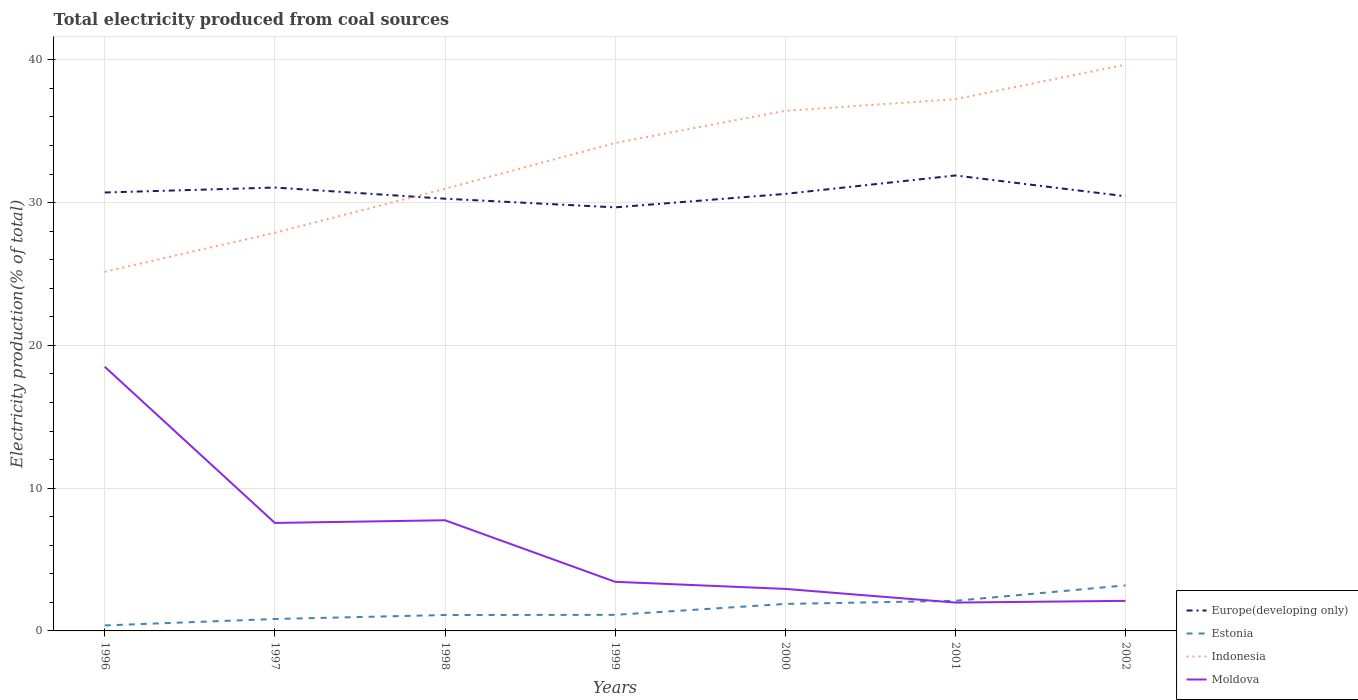How many different coloured lines are there?
Offer a very short reply. 4. Does the line corresponding to Estonia intersect with the line corresponding to Indonesia?
Your answer should be very brief. No. Across all years, what is the maximum total electricity produced in Estonia?
Keep it short and to the point. 0.38. What is the total total electricity produced in Indonesia in the graph?
Your response must be concise. -14.51. What is the difference between the highest and the second highest total electricity produced in Moldova?
Make the answer very short. 16.52. How many years are there in the graph?
Make the answer very short. 7. What is the difference between two consecutive major ticks on the Y-axis?
Provide a short and direct response. 10. Does the graph contain grids?
Offer a terse response. Yes. How are the legend labels stacked?
Provide a succinct answer. Vertical. What is the title of the graph?
Ensure brevity in your answer.  Total electricity produced from coal sources. What is the label or title of the X-axis?
Make the answer very short. Years. What is the Electricity production(% of total) of Europe(developing only) in 1996?
Provide a short and direct response. 30.71. What is the Electricity production(% of total) of Estonia in 1996?
Provide a short and direct response. 0.38. What is the Electricity production(% of total) of Indonesia in 1996?
Ensure brevity in your answer.  25.16. What is the Electricity production(% of total) of Moldova in 1996?
Your answer should be compact. 18.5. What is the Electricity production(% of total) of Europe(developing only) in 1997?
Your answer should be very brief. 31.06. What is the Electricity production(% of total) of Estonia in 1997?
Provide a short and direct response. 0.84. What is the Electricity production(% of total) of Indonesia in 1997?
Make the answer very short. 27.89. What is the Electricity production(% of total) in Moldova in 1997?
Offer a very short reply. 7.56. What is the Electricity production(% of total) of Europe(developing only) in 1998?
Your response must be concise. 30.28. What is the Electricity production(% of total) of Estonia in 1998?
Your answer should be very brief. 1.11. What is the Electricity production(% of total) of Indonesia in 1998?
Your answer should be compact. 30.97. What is the Electricity production(% of total) in Moldova in 1998?
Keep it short and to the point. 7.75. What is the Electricity production(% of total) of Europe(developing only) in 1999?
Give a very brief answer. 29.67. What is the Electricity production(% of total) in Estonia in 1999?
Make the answer very short. 1.12. What is the Electricity production(% of total) in Indonesia in 1999?
Provide a succinct answer. 34.18. What is the Electricity production(% of total) of Moldova in 1999?
Your answer should be very brief. 3.44. What is the Electricity production(% of total) of Europe(developing only) in 2000?
Offer a terse response. 30.61. What is the Electricity production(% of total) in Estonia in 2000?
Provide a short and direct response. 1.89. What is the Electricity production(% of total) of Indonesia in 2000?
Give a very brief answer. 36.43. What is the Electricity production(% of total) of Moldova in 2000?
Offer a terse response. 2.94. What is the Electricity production(% of total) of Europe(developing only) in 2001?
Offer a very short reply. 31.9. What is the Electricity production(% of total) in Estonia in 2001?
Your response must be concise. 2.11. What is the Electricity production(% of total) of Indonesia in 2001?
Give a very brief answer. 37.25. What is the Electricity production(% of total) of Moldova in 2001?
Keep it short and to the point. 1.99. What is the Electricity production(% of total) of Europe(developing only) in 2002?
Your answer should be very brief. 30.45. What is the Electricity production(% of total) of Estonia in 2002?
Your answer should be compact. 3.19. What is the Electricity production(% of total) in Indonesia in 2002?
Offer a very short reply. 39.67. What is the Electricity production(% of total) of Moldova in 2002?
Your answer should be very brief. 2.11. Across all years, what is the maximum Electricity production(% of total) in Europe(developing only)?
Make the answer very short. 31.9. Across all years, what is the maximum Electricity production(% of total) in Estonia?
Your response must be concise. 3.19. Across all years, what is the maximum Electricity production(% of total) in Indonesia?
Provide a short and direct response. 39.67. Across all years, what is the maximum Electricity production(% of total) in Moldova?
Provide a short and direct response. 18.5. Across all years, what is the minimum Electricity production(% of total) of Europe(developing only)?
Your answer should be very brief. 29.67. Across all years, what is the minimum Electricity production(% of total) in Estonia?
Your answer should be compact. 0.38. Across all years, what is the minimum Electricity production(% of total) in Indonesia?
Your answer should be very brief. 25.16. Across all years, what is the minimum Electricity production(% of total) in Moldova?
Provide a succinct answer. 1.99. What is the total Electricity production(% of total) in Europe(developing only) in the graph?
Your response must be concise. 214.68. What is the total Electricity production(% of total) of Estonia in the graph?
Provide a short and direct response. 10.65. What is the total Electricity production(% of total) of Indonesia in the graph?
Your response must be concise. 231.55. What is the total Electricity production(% of total) in Moldova in the graph?
Keep it short and to the point. 44.3. What is the difference between the Electricity production(% of total) of Europe(developing only) in 1996 and that in 1997?
Keep it short and to the point. -0.35. What is the difference between the Electricity production(% of total) of Estonia in 1996 and that in 1997?
Provide a short and direct response. -0.45. What is the difference between the Electricity production(% of total) in Indonesia in 1996 and that in 1997?
Offer a terse response. -2.74. What is the difference between the Electricity production(% of total) of Moldova in 1996 and that in 1997?
Make the answer very short. 10.94. What is the difference between the Electricity production(% of total) in Europe(developing only) in 1996 and that in 1998?
Offer a terse response. 0.44. What is the difference between the Electricity production(% of total) in Estonia in 1996 and that in 1998?
Offer a very short reply. -0.73. What is the difference between the Electricity production(% of total) of Indonesia in 1996 and that in 1998?
Offer a very short reply. -5.81. What is the difference between the Electricity production(% of total) in Moldova in 1996 and that in 1998?
Make the answer very short. 10.75. What is the difference between the Electricity production(% of total) of Europe(developing only) in 1996 and that in 1999?
Provide a short and direct response. 1.04. What is the difference between the Electricity production(% of total) of Estonia in 1996 and that in 1999?
Your answer should be very brief. -0.74. What is the difference between the Electricity production(% of total) in Indonesia in 1996 and that in 1999?
Offer a very short reply. -9.02. What is the difference between the Electricity production(% of total) of Moldova in 1996 and that in 1999?
Provide a succinct answer. 15.06. What is the difference between the Electricity production(% of total) in Europe(developing only) in 1996 and that in 2000?
Offer a terse response. 0.1. What is the difference between the Electricity production(% of total) in Estonia in 1996 and that in 2000?
Give a very brief answer. -1.51. What is the difference between the Electricity production(% of total) of Indonesia in 1996 and that in 2000?
Your answer should be compact. -11.28. What is the difference between the Electricity production(% of total) of Moldova in 1996 and that in 2000?
Offer a terse response. 15.56. What is the difference between the Electricity production(% of total) in Europe(developing only) in 1996 and that in 2001?
Keep it short and to the point. -1.19. What is the difference between the Electricity production(% of total) in Estonia in 1996 and that in 2001?
Your answer should be compact. -1.73. What is the difference between the Electricity production(% of total) of Indonesia in 1996 and that in 2001?
Ensure brevity in your answer.  -12.09. What is the difference between the Electricity production(% of total) of Moldova in 1996 and that in 2001?
Your answer should be very brief. 16.52. What is the difference between the Electricity production(% of total) of Europe(developing only) in 1996 and that in 2002?
Keep it short and to the point. 0.26. What is the difference between the Electricity production(% of total) in Estonia in 1996 and that in 2002?
Offer a terse response. -2.81. What is the difference between the Electricity production(% of total) of Indonesia in 1996 and that in 2002?
Offer a terse response. -14.51. What is the difference between the Electricity production(% of total) in Moldova in 1996 and that in 2002?
Make the answer very short. 16.4. What is the difference between the Electricity production(% of total) of Europe(developing only) in 1997 and that in 1998?
Give a very brief answer. 0.78. What is the difference between the Electricity production(% of total) in Estonia in 1997 and that in 1998?
Your answer should be very brief. -0.28. What is the difference between the Electricity production(% of total) of Indonesia in 1997 and that in 1998?
Your answer should be very brief. -3.08. What is the difference between the Electricity production(% of total) of Moldova in 1997 and that in 1998?
Make the answer very short. -0.19. What is the difference between the Electricity production(% of total) in Europe(developing only) in 1997 and that in 1999?
Provide a succinct answer. 1.39. What is the difference between the Electricity production(% of total) in Estonia in 1997 and that in 1999?
Your answer should be very brief. -0.29. What is the difference between the Electricity production(% of total) of Indonesia in 1997 and that in 1999?
Offer a terse response. -6.29. What is the difference between the Electricity production(% of total) in Moldova in 1997 and that in 1999?
Your response must be concise. 4.12. What is the difference between the Electricity production(% of total) of Europe(developing only) in 1997 and that in 2000?
Ensure brevity in your answer.  0.45. What is the difference between the Electricity production(% of total) of Estonia in 1997 and that in 2000?
Offer a very short reply. -1.06. What is the difference between the Electricity production(% of total) of Indonesia in 1997 and that in 2000?
Offer a terse response. -8.54. What is the difference between the Electricity production(% of total) in Moldova in 1997 and that in 2000?
Provide a short and direct response. 4.62. What is the difference between the Electricity production(% of total) in Europe(developing only) in 1997 and that in 2001?
Your answer should be compact. -0.85. What is the difference between the Electricity production(% of total) of Estonia in 1997 and that in 2001?
Keep it short and to the point. -1.27. What is the difference between the Electricity production(% of total) in Indonesia in 1997 and that in 2001?
Your response must be concise. -9.35. What is the difference between the Electricity production(% of total) of Moldova in 1997 and that in 2001?
Give a very brief answer. 5.58. What is the difference between the Electricity production(% of total) of Europe(developing only) in 1997 and that in 2002?
Your answer should be very brief. 0.61. What is the difference between the Electricity production(% of total) in Estonia in 1997 and that in 2002?
Make the answer very short. -2.35. What is the difference between the Electricity production(% of total) in Indonesia in 1997 and that in 2002?
Give a very brief answer. -11.78. What is the difference between the Electricity production(% of total) of Moldova in 1997 and that in 2002?
Ensure brevity in your answer.  5.46. What is the difference between the Electricity production(% of total) in Europe(developing only) in 1998 and that in 1999?
Provide a short and direct response. 0.61. What is the difference between the Electricity production(% of total) of Estonia in 1998 and that in 1999?
Offer a terse response. -0.01. What is the difference between the Electricity production(% of total) of Indonesia in 1998 and that in 1999?
Your response must be concise. -3.21. What is the difference between the Electricity production(% of total) in Moldova in 1998 and that in 1999?
Ensure brevity in your answer.  4.31. What is the difference between the Electricity production(% of total) in Europe(developing only) in 1998 and that in 2000?
Provide a succinct answer. -0.34. What is the difference between the Electricity production(% of total) of Estonia in 1998 and that in 2000?
Give a very brief answer. -0.78. What is the difference between the Electricity production(% of total) of Indonesia in 1998 and that in 2000?
Your response must be concise. -5.46. What is the difference between the Electricity production(% of total) of Moldova in 1998 and that in 2000?
Your answer should be very brief. 4.81. What is the difference between the Electricity production(% of total) of Europe(developing only) in 1998 and that in 2001?
Provide a short and direct response. -1.63. What is the difference between the Electricity production(% of total) of Estonia in 1998 and that in 2001?
Keep it short and to the point. -1. What is the difference between the Electricity production(% of total) of Indonesia in 1998 and that in 2001?
Offer a terse response. -6.27. What is the difference between the Electricity production(% of total) in Moldova in 1998 and that in 2001?
Provide a short and direct response. 5.77. What is the difference between the Electricity production(% of total) of Europe(developing only) in 1998 and that in 2002?
Your response must be concise. -0.17. What is the difference between the Electricity production(% of total) in Estonia in 1998 and that in 2002?
Offer a very short reply. -2.08. What is the difference between the Electricity production(% of total) of Indonesia in 1998 and that in 2002?
Give a very brief answer. -8.7. What is the difference between the Electricity production(% of total) in Moldova in 1998 and that in 2002?
Provide a short and direct response. 5.65. What is the difference between the Electricity production(% of total) of Europe(developing only) in 1999 and that in 2000?
Keep it short and to the point. -0.94. What is the difference between the Electricity production(% of total) in Estonia in 1999 and that in 2000?
Give a very brief answer. -0.77. What is the difference between the Electricity production(% of total) in Indonesia in 1999 and that in 2000?
Provide a succinct answer. -2.25. What is the difference between the Electricity production(% of total) of Moldova in 1999 and that in 2000?
Ensure brevity in your answer.  0.5. What is the difference between the Electricity production(% of total) in Europe(developing only) in 1999 and that in 2001?
Your answer should be compact. -2.23. What is the difference between the Electricity production(% of total) of Estonia in 1999 and that in 2001?
Keep it short and to the point. -0.99. What is the difference between the Electricity production(% of total) of Indonesia in 1999 and that in 2001?
Make the answer very short. -3.07. What is the difference between the Electricity production(% of total) of Moldova in 1999 and that in 2001?
Your answer should be compact. 1.45. What is the difference between the Electricity production(% of total) of Europe(developing only) in 1999 and that in 2002?
Provide a short and direct response. -0.78. What is the difference between the Electricity production(% of total) in Estonia in 1999 and that in 2002?
Ensure brevity in your answer.  -2.06. What is the difference between the Electricity production(% of total) in Indonesia in 1999 and that in 2002?
Provide a short and direct response. -5.49. What is the difference between the Electricity production(% of total) in Moldova in 1999 and that in 2002?
Your answer should be compact. 1.33. What is the difference between the Electricity production(% of total) in Europe(developing only) in 2000 and that in 2001?
Make the answer very short. -1.29. What is the difference between the Electricity production(% of total) in Estonia in 2000 and that in 2001?
Keep it short and to the point. -0.22. What is the difference between the Electricity production(% of total) in Indonesia in 2000 and that in 2001?
Your response must be concise. -0.81. What is the difference between the Electricity production(% of total) of Moldova in 2000 and that in 2001?
Your response must be concise. 0.96. What is the difference between the Electricity production(% of total) in Europe(developing only) in 2000 and that in 2002?
Your answer should be very brief. 0.16. What is the difference between the Electricity production(% of total) of Estonia in 2000 and that in 2002?
Ensure brevity in your answer.  -1.3. What is the difference between the Electricity production(% of total) in Indonesia in 2000 and that in 2002?
Offer a terse response. -3.24. What is the difference between the Electricity production(% of total) of Moldova in 2000 and that in 2002?
Provide a succinct answer. 0.84. What is the difference between the Electricity production(% of total) of Europe(developing only) in 2001 and that in 2002?
Your answer should be very brief. 1.45. What is the difference between the Electricity production(% of total) in Estonia in 2001 and that in 2002?
Keep it short and to the point. -1.08. What is the difference between the Electricity production(% of total) of Indonesia in 2001 and that in 2002?
Your answer should be very brief. -2.42. What is the difference between the Electricity production(% of total) in Moldova in 2001 and that in 2002?
Your answer should be very brief. -0.12. What is the difference between the Electricity production(% of total) of Europe(developing only) in 1996 and the Electricity production(% of total) of Estonia in 1997?
Give a very brief answer. 29.88. What is the difference between the Electricity production(% of total) of Europe(developing only) in 1996 and the Electricity production(% of total) of Indonesia in 1997?
Make the answer very short. 2.82. What is the difference between the Electricity production(% of total) in Europe(developing only) in 1996 and the Electricity production(% of total) in Moldova in 1997?
Your answer should be very brief. 23.15. What is the difference between the Electricity production(% of total) in Estonia in 1996 and the Electricity production(% of total) in Indonesia in 1997?
Your answer should be very brief. -27.51. What is the difference between the Electricity production(% of total) in Estonia in 1996 and the Electricity production(% of total) in Moldova in 1997?
Ensure brevity in your answer.  -7.18. What is the difference between the Electricity production(% of total) of Indonesia in 1996 and the Electricity production(% of total) of Moldova in 1997?
Ensure brevity in your answer.  17.59. What is the difference between the Electricity production(% of total) of Europe(developing only) in 1996 and the Electricity production(% of total) of Estonia in 1998?
Ensure brevity in your answer.  29.6. What is the difference between the Electricity production(% of total) in Europe(developing only) in 1996 and the Electricity production(% of total) in Indonesia in 1998?
Provide a short and direct response. -0.26. What is the difference between the Electricity production(% of total) of Europe(developing only) in 1996 and the Electricity production(% of total) of Moldova in 1998?
Your answer should be compact. 22.96. What is the difference between the Electricity production(% of total) of Estonia in 1996 and the Electricity production(% of total) of Indonesia in 1998?
Provide a short and direct response. -30.59. What is the difference between the Electricity production(% of total) of Estonia in 1996 and the Electricity production(% of total) of Moldova in 1998?
Ensure brevity in your answer.  -7.37. What is the difference between the Electricity production(% of total) of Indonesia in 1996 and the Electricity production(% of total) of Moldova in 1998?
Your answer should be compact. 17.41. What is the difference between the Electricity production(% of total) of Europe(developing only) in 1996 and the Electricity production(% of total) of Estonia in 1999?
Ensure brevity in your answer.  29.59. What is the difference between the Electricity production(% of total) of Europe(developing only) in 1996 and the Electricity production(% of total) of Indonesia in 1999?
Your answer should be compact. -3.47. What is the difference between the Electricity production(% of total) of Europe(developing only) in 1996 and the Electricity production(% of total) of Moldova in 1999?
Your answer should be compact. 27.27. What is the difference between the Electricity production(% of total) in Estonia in 1996 and the Electricity production(% of total) in Indonesia in 1999?
Make the answer very short. -33.79. What is the difference between the Electricity production(% of total) of Estonia in 1996 and the Electricity production(% of total) of Moldova in 1999?
Offer a very short reply. -3.06. What is the difference between the Electricity production(% of total) in Indonesia in 1996 and the Electricity production(% of total) in Moldova in 1999?
Provide a short and direct response. 21.72. What is the difference between the Electricity production(% of total) in Europe(developing only) in 1996 and the Electricity production(% of total) in Estonia in 2000?
Your answer should be compact. 28.82. What is the difference between the Electricity production(% of total) in Europe(developing only) in 1996 and the Electricity production(% of total) in Indonesia in 2000?
Offer a very short reply. -5.72. What is the difference between the Electricity production(% of total) of Europe(developing only) in 1996 and the Electricity production(% of total) of Moldova in 2000?
Provide a short and direct response. 27.77. What is the difference between the Electricity production(% of total) in Estonia in 1996 and the Electricity production(% of total) in Indonesia in 2000?
Your response must be concise. -36.05. What is the difference between the Electricity production(% of total) in Estonia in 1996 and the Electricity production(% of total) in Moldova in 2000?
Give a very brief answer. -2.56. What is the difference between the Electricity production(% of total) in Indonesia in 1996 and the Electricity production(% of total) in Moldova in 2000?
Provide a short and direct response. 22.21. What is the difference between the Electricity production(% of total) of Europe(developing only) in 1996 and the Electricity production(% of total) of Estonia in 2001?
Your response must be concise. 28.6. What is the difference between the Electricity production(% of total) of Europe(developing only) in 1996 and the Electricity production(% of total) of Indonesia in 2001?
Give a very brief answer. -6.53. What is the difference between the Electricity production(% of total) of Europe(developing only) in 1996 and the Electricity production(% of total) of Moldova in 2001?
Provide a short and direct response. 28.73. What is the difference between the Electricity production(% of total) in Estonia in 1996 and the Electricity production(% of total) in Indonesia in 2001?
Offer a terse response. -36.86. What is the difference between the Electricity production(% of total) of Estonia in 1996 and the Electricity production(% of total) of Moldova in 2001?
Your answer should be compact. -1.6. What is the difference between the Electricity production(% of total) of Indonesia in 1996 and the Electricity production(% of total) of Moldova in 2001?
Your answer should be compact. 23.17. What is the difference between the Electricity production(% of total) of Europe(developing only) in 1996 and the Electricity production(% of total) of Estonia in 2002?
Offer a terse response. 27.52. What is the difference between the Electricity production(% of total) in Europe(developing only) in 1996 and the Electricity production(% of total) in Indonesia in 2002?
Keep it short and to the point. -8.96. What is the difference between the Electricity production(% of total) in Europe(developing only) in 1996 and the Electricity production(% of total) in Moldova in 2002?
Your answer should be compact. 28.61. What is the difference between the Electricity production(% of total) of Estonia in 1996 and the Electricity production(% of total) of Indonesia in 2002?
Provide a succinct answer. -39.28. What is the difference between the Electricity production(% of total) in Estonia in 1996 and the Electricity production(% of total) in Moldova in 2002?
Your answer should be very brief. -1.72. What is the difference between the Electricity production(% of total) of Indonesia in 1996 and the Electricity production(% of total) of Moldova in 2002?
Your response must be concise. 23.05. What is the difference between the Electricity production(% of total) in Europe(developing only) in 1997 and the Electricity production(% of total) in Estonia in 1998?
Provide a succinct answer. 29.94. What is the difference between the Electricity production(% of total) in Europe(developing only) in 1997 and the Electricity production(% of total) in Indonesia in 1998?
Offer a terse response. 0.09. What is the difference between the Electricity production(% of total) in Europe(developing only) in 1997 and the Electricity production(% of total) in Moldova in 1998?
Your answer should be very brief. 23.31. What is the difference between the Electricity production(% of total) in Estonia in 1997 and the Electricity production(% of total) in Indonesia in 1998?
Ensure brevity in your answer.  -30.14. What is the difference between the Electricity production(% of total) of Estonia in 1997 and the Electricity production(% of total) of Moldova in 1998?
Ensure brevity in your answer.  -6.92. What is the difference between the Electricity production(% of total) of Indonesia in 1997 and the Electricity production(% of total) of Moldova in 1998?
Ensure brevity in your answer.  20.14. What is the difference between the Electricity production(% of total) of Europe(developing only) in 1997 and the Electricity production(% of total) of Estonia in 1999?
Keep it short and to the point. 29.93. What is the difference between the Electricity production(% of total) of Europe(developing only) in 1997 and the Electricity production(% of total) of Indonesia in 1999?
Offer a very short reply. -3.12. What is the difference between the Electricity production(% of total) of Europe(developing only) in 1997 and the Electricity production(% of total) of Moldova in 1999?
Provide a succinct answer. 27.62. What is the difference between the Electricity production(% of total) of Estonia in 1997 and the Electricity production(% of total) of Indonesia in 1999?
Make the answer very short. -33.34. What is the difference between the Electricity production(% of total) in Estonia in 1997 and the Electricity production(% of total) in Moldova in 1999?
Your answer should be compact. -2.61. What is the difference between the Electricity production(% of total) in Indonesia in 1997 and the Electricity production(% of total) in Moldova in 1999?
Keep it short and to the point. 24.45. What is the difference between the Electricity production(% of total) in Europe(developing only) in 1997 and the Electricity production(% of total) in Estonia in 2000?
Provide a succinct answer. 29.17. What is the difference between the Electricity production(% of total) in Europe(developing only) in 1997 and the Electricity production(% of total) in Indonesia in 2000?
Offer a very short reply. -5.38. What is the difference between the Electricity production(% of total) of Europe(developing only) in 1997 and the Electricity production(% of total) of Moldova in 2000?
Make the answer very short. 28.12. What is the difference between the Electricity production(% of total) in Estonia in 1997 and the Electricity production(% of total) in Indonesia in 2000?
Your answer should be compact. -35.6. What is the difference between the Electricity production(% of total) in Estonia in 1997 and the Electricity production(% of total) in Moldova in 2000?
Your answer should be very brief. -2.11. What is the difference between the Electricity production(% of total) in Indonesia in 1997 and the Electricity production(% of total) in Moldova in 2000?
Offer a terse response. 24.95. What is the difference between the Electricity production(% of total) of Europe(developing only) in 1997 and the Electricity production(% of total) of Estonia in 2001?
Ensure brevity in your answer.  28.95. What is the difference between the Electricity production(% of total) in Europe(developing only) in 1997 and the Electricity production(% of total) in Indonesia in 2001?
Make the answer very short. -6.19. What is the difference between the Electricity production(% of total) of Europe(developing only) in 1997 and the Electricity production(% of total) of Moldova in 2001?
Provide a short and direct response. 29.07. What is the difference between the Electricity production(% of total) in Estonia in 1997 and the Electricity production(% of total) in Indonesia in 2001?
Your answer should be compact. -36.41. What is the difference between the Electricity production(% of total) of Estonia in 1997 and the Electricity production(% of total) of Moldova in 2001?
Offer a terse response. -1.15. What is the difference between the Electricity production(% of total) in Indonesia in 1997 and the Electricity production(% of total) in Moldova in 2001?
Ensure brevity in your answer.  25.91. What is the difference between the Electricity production(% of total) of Europe(developing only) in 1997 and the Electricity production(% of total) of Estonia in 2002?
Ensure brevity in your answer.  27.87. What is the difference between the Electricity production(% of total) in Europe(developing only) in 1997 and the Electricity production(% of total) in Indonesia in 2002?
Your answer should be very brief. -8.61. What is the difference between the Electricity production(% of total) in Europe(developing only) in 1997 and the Electricity production(% of total) in Moldova in 2002?
Ensure brevity in your answer.  28.95. What is the difference between the Electricity production(% of total) in Estonia in 1997 and the Electricity production(% of total) in Indonesia in 2002?
Provide a short and direct response. -38.83. What is the difference between the Electricity production(% of total) in Estonia in 1997 and the Electricity production(% of total) in Moldova in 2002?
Offer a terse response. -1.27. What is the difference between the Electricity production(% of total) in Indonesia in 1997 and the Electricity production(% of total) in Moldova in 2002?
Your answer should be very brief. 25.79. What is the difference between the Electricity production(% of total) of Europe(developing only) in 1998 and the Electricity production(% of total) of Estonia in 1999?
Offer a terse response. 29.15. What is the difference between the Electricity production(% of total) in Europe(developing only) in 1998 and the Electricity production(% of total) in Indonesia in 1999?
Offer a terse response. -3.9. What is the difference between the Electricity production(% of total) of Europe(developing only) in 1998 and the Electricity production(% of total) of Moldova in 1999?
Offer a terse response. 26.84. What is the difference between the Electricity production(% of total) in Estonia in 1998 and the Electricity production(% of total) in Indonesia in 1999?
Make the answer very short. -33.06. What is the difference between the Electricity production(% of total) of Estonia in 1998 and the Electricity production(% of total) of Moldova in 1999?
Your response must be concise. -2.33. What is the difference between the Electricity production(% of total) of Indonesia in 1998 and the Electricity production(% of total) of Moldova in 1999?
Ensure brevity in your answer.  27.53. What is the difference between the Electricity production(% of total) in Europe(developing only) in 1998 and the Electricity production(% of total) in Estonia in 2000?
Offer a very short reply. 28.38. What is the difference between the Electricity production(% of total) in Europe(developing only) in 1998 and the Electricity production(% of total) in Indonesia in 2000?
Your response must be concise. -6.16. What is the difference between the Electricity production(% of total) in Europe(developing only) in 1998 and the Electricity production(% of total) in Moldova in 2000?
Make the answer very short. 27.33. What is the difference between the Electricity production(% of total) of Estonia in 1998 and the Electricity production(% of total) of Indonesia in 2000?
Your answer should be very brief. -35.32. What is the difference between the Electricity production(% of total) in Estonia in 1998 and the Electricity production(% of total) in Moldova in 2000?
Ensure brevity in your answer.  -1.83. What is the difference between the Electricity production(% of total) of Indonesia in 1998 and the Electricity production(% of total) of Moldova in 2000?
Make the answer very short. 28.03. What is the difference between the Electricity production(% of total) of Europe(developing only) in 1998 and the Electricity production(% of total) of Estonia in 2001?
Your answer should be compact. 28.17. What is the difference between the Electricity production(% of total) of Europe(developing only) in 1998 and the Electricity production(% of total) of Indonesia in 2001?
Provide a succinct answer. -6.97. What is the difference between the Electricity production(% of total) of Europe(developing only) in 1998 and the Electricity production(% of total) of Moldova in 2001?
Offer a terse response. 28.29. What is the difference between the Electricity production(% of total) of Estonia in 1998 and the Electricity production(% of total) of Indonesia in 2001?
Provide a short and direct response. -36.13. What is the difference between the Electricity production(% of total) in Estonia in 1998 and the Electricity production(% of total) in Moldova in 2001?
Your answer should be very brief. -0.87. What is the difference between the Electricity production(% of total) of Indonesia in 1998 and the Electricity production(% of total) of Moldova in 2001?
Ensure brevity in your answer.  28.99. What is the difference between the Electricity production(% of total) of Europe(developing only) in 1998 and the Electricity production(% of total) of Estonia in 2002?
Offer a terse response. 27.09. What is the difference between the Electricity production(% of total) of Europe(developing only) in 1998 and the Electricity production(% of total) of Indonesia in 2002?
Provide a short and direct response. -9.39. What is the difference between the Electricity production(% of total) of Europe(developing only) in 1998 and the Electricity production(% of total) of Moldova in 2002?
Provide a succinct answer. 28.17. What is the difference between the Electricity production(% of total) of Estonia in 1998 and the Electricity production(% of total) of Indonesia in 2002?
Offer a very short reply. -38.55. What is the difference between the Electricity production(% of total) of Estonia in 1998 and the Electricity production(% of total) of Moldova in 2002?
Keep it short and to the point. -0.99. What is the difference between the Electricity production(% of total) in Indonesia in 1998 and the Electricity production(% of total) in Moldova in 2002?
Offer a terse response. 28.87. What is the difference between the Electricity production(% of total) of Europe(developing only) in 1999 and the Electricity production(% of total) of Estonia in 2000?
Your response must be concise. 27.78. What is the difference between the Electricity production(% of total) of Europe(developing only) in 1999 and the Electricity production(% of total) of Indonesia in 2000?
Make the answer very short. -6.76. What is the difference between the Electricity production(% of total) of Europe(developing only) in 1999 and the Electricity production(% of total) of Moldova in 2000?
Make the answer very short. 26.73. What is the difference between the Electricity production(% of total) in Estonia in 1999 and the Electricity production(% of total) in Indonesia in 2000?
Your answer should be very brief. -35.31. What is the difference between the Electricity production(% of total) in Estonia in 1999 and the Electricity production(% of total) in Moldova in 2000?
Offer a very short reply. -1.82. What is the difference between the Electricity production(% of total) in Indonesia in 1999 and the Electricity production(% of total) in Moldova in 2000?
Offer a terse response. 31.24. What is the difference between the Electricity production(% of total) in Europe(developing only) in 1999 and the Electricity production(% of total) in Estonia in 2001?
Provide a succinct answer. 27.56. What is the difference between the Electricity production(% of total) of Europe(developing only) in 1999 and the Electricity production(% of total) of Indonesia in 2001?
Make the answer very short. -7.58. What is the difference between the Electricity production(% of total) in Europe(developing only) in 1999 and the Electricity production(% of total) in Moldova in 2001?
Ensure brevity in your answer.  27.68. What is the difference between the Electricity production(% of total) of Estonia in 1999 and the Electricity production(% of total) of Indonesia in 2001?
Provide a short and direct response. -36.12. What is the difference between the Electricity production(% of total) in Estonia in 1999 and the Electricity production(% of total) in Moldova in 2001?
Your answer should be very brief. -0.86. What is the difference between the Electricity production(% of total) in Indonesia in 1999 and the Electricity production(% of total) in Moldova in 2001?
Ensure brevity in your answer.  32.19. What is the difference between the Electricity production(% of total) in Europe(developing only) in 1999 and the Electricity production(% of total) in Estonia in 2002?
Give a very brief answer. 26.48. What is the difference between the Electricity production(% of total) of Europe(developing only) in 1999 and the Electricity production(% of total) of Indonesia in 2002?
Keep it short and to the point. -10. What is the difference between the Electricity production(% of total) in Europe(developing only) in 1999 and the Electricity production(% of total) in Moldova in 2002?
Offer a terse response. 27.56. What is the difference between the Electricity production(% of total) of Estonia in 1999 and the Electricity production(% of total) of Indonesia in 2002?
Provide a succinct answer. -38.54. What is the difference between the Electricity production(% of total) of Estonia in 1999 and the Electricity production(% of total) of Moldova in 2002?
Your answer should be very brief. -0.98. What is the difference between the Electricity production(% of total) of Indonesia in 1999 and the Electricity production(% of total) of Moldova in 2002?
Offer a terse response. 32.07. What is the difference between the Electricity production(% of total) of Europe(developing only) in 2000 and the Electricity production(% of total) of Estonia in 2001?
Your response must be concise. 28.5. What is the difference between the Electricity production(% of total) of Europe(developing only) in 2000 and the Electricity production(% of total) of Indonesia in 2001?
Keep it short and to the point. -6.63. What is the difference between the Electricity production(% of total) of Europe(developing only) in 2000 and the Electricity production(% of total) of Moldova in 2001?
Offer a terse response. 28.63. What is the difference between the Electricity production(% of total) of Estonia in 2000 and the Electricity production(% of total) of Indonesia in 2001?
Ensure brevity in your answer.  -35.35. What is the difference between the Electricity production(% of total) in Estonia in 2000 and the Electricity production(% of total) in Moldova in 2001?
Provide a succinct answer. -0.1. What is the difference between the Electricity production(% of total) in Indonesia in 2000 and the Electricity production(% of total) in Moldova in 2001?
Your response must be concise. 34.45. What is the difference between the Electricity production(% of total) in Europe(developing only) in 2000 and the Electricity production(% of total) in Estonia in 2002?
Keep it short and to the point. 27.42. What is the difference between the Electricity production(% of total) in Europe(developing only) in 2000 and the Electricity production(% of total) in Indonesia in 2002?
Your answer should be very brief. -9.06. What is the difference between the Electricity production(% of total) of Europe(developing only) in 2000 and the Electricity production(% of total) of Moldova in 2002?
Provide a short and direct response. 28.51. What is the difference between the Electricity production(% of total) of Estonia in 2000 and the Electricity production(% of total) of Indonesia in 2002?
Your response must be concise. -37.78. What is the difference between the Electricity production(% of total) in Estonia in 2000 and the Electricity production(% of total) in Moldova in 2002?
Keep it short and to the point. -0.21. What is the difference between the Electricity production(% of total) in Indonesia in 2000 and the Electricity production(% of total) in Moldova in 2002?
Keep it short and to the point. 34.33. What is the difference between the Electricity production(% of total) in Europe(developing only) in 2001 and the Electricity production(% of total) in Estonia in 2002?
Your answer should be very brief. 28.71. What is the difference between the Electricity production(% of total) of Europe(developing only) in 2001 and the Electricity production(% of total) of Indonesia in 2002?
Make the answer very short. -7.77. What is the difference between the Electricity production(% of total) in Europe(developing only) in 2001 and the Electricity production(% of total) in Moldova in 2002?
Offer a terse response. 29.8. What is the difference between the Electricity production(% of total) in Estonia in 2001 and the Electricity production(% of total) in Indonesia in 2002?
Give a very brief answer. -37.56. What is the difference between the Electricity production(% of total) in Estonia in 2001 and the Electricity production(% of total) in Moldova in 2002?
Provide a succinct answer. 0. What is the difference between the Electricity production(% of total) in Indonesia in 2001 and the Electricity production(% of total) in Moldova in 2002?
Keep it short and to the point. 35.14. What is the average Electricity production(% of total) in Europe(developing only) per year?
Ensure brevity in your answer.  30.67. What is the average Electricity production(% of total) in Estonia per year?
Make the answer very short. 1.52. What is the average Electricity production(% of total) of Indonesia per year?
Offer a terse response. 33.08. What is the average Electricity production(% of total) in Moldova per year?
Your response must be concise. 6.33. In the year 1996, what is the difference between the Electricity production(% of total) of Europe(developing only) and Electricity production(% of total) of Estonia?
Ensure brevity in your answer.  30.33. In the year 1996, what is the difference between the Electricity production(% of total) in Europe(developing only) and Electricity production(% of total) in Indonesia?
Your answer should be compact. 5.55. In the year 1996, what is the difference between the Electricity production(% of total) of Europe(developing only) and Electricity production(% of total) of Moldova?
Keep it short and to the point. 12.21. In the year 1996, what is the difference between the Electricity production(% of total) of Estonia and Electricity production(% of total) of Indonesia?
Offer a very short reply. -24.77. In the year 1996, what is the difference between the Electricity production(% of total) in Estonia and Electricity production(% of total) in Moldova?
Your answer should be compact. -18.12. In the year 1996, what is the difference between the Electricity production(% of total) of Indonesia and Electricity production(% of total) of Moldova?
Make the answer very short. 6.65. In the year 1997, what is the difference between the Electricity production(% of total) in Europe(developing only) and Electricity production(% of total) in Estonia?
Ensure brevity in your answer.  30.22. In the year 1997, what is the difference between the Electricity production(% of total) in Europe(developing only) and Electricity production(% of total) in Indonesia?
Your answer should be very brief. 3.17. In the year 1997, what is the difference between the Electricity production(% of total) in Europe(developing only) and Electricity production(% of total) in Moldova?
Your answer should be very brief. 23.49. In the year 1997, what is the difference between the Electricity production(% of total) in Estonia and Electricity production(% of total) in Indonesia?
Provide a succinct answer. -27.06. In the year 1997, what is the difference between the Electricity production(% of total) in Estonia and Electricity production(% of total) in Moldova?
Make the answer very short. -6.73. In the year 1997, what is the difference between the Electricity production(% of total) of Indonesia and Electricity production(% of total) of Moldova?
Offer a very short reply. 20.33. In the year 1998, what is the difference between the Electricity production(% of total) in Europe(developing only) and Electricity production(% of total) in Estonia?
Provide a short and direct response. 29.16. In the year 1998, what is the difference between the Electricity production(% of total) in Europe(developing only) and Electricity production(% of total) in Indonesia?
Your response must be concise. -0.7. In the year 1998, what is the difference between the Electricity production(% of total) in Europe(developing only) and Electricity production(% of total) in Moldova?
Your response must be concise. 22.52. In the year 1998, what is the difference between the Electricity production(% of total) of Estonia and Electricity production(% of total) of Indonesia?
Provide a succinct answer. -29.86. In the year 1998, what is the difference between the Electricity production(% of total) in Estonia and Electricity production(% of total) in Moldova?
Your answer should be very brief. -6.64. In the year 1998, what is the difference between the Electricity production(% of total) of Indonesia and Electricity production(% of total) of Moldova?
Your answer should be very brief. 23.22. In the year 1999, what is the difference between the Electricity production(% of total) in Europe(developing only) and Electricity production(% of total) in Estonia?
Provide a short and direct response. 28.55. In the year 1999, what is the difference between the Electricity production(% of total) of Europe(developing only) and Electricity production(% of total) of Indonesia?
Provide a succinct answer. -4.51. In the year 1999, what is the difference between the Electricity production(% of total) in Europe(developing only) and Electricity production(% of total) in Moldova?
Offer a terse response. 26.23. In the year 1999, what is the difference between the Electricity production(% of total) of Estonia and Electricity production(% of total) of Indonesia?
Provide a succinct answer. -33.05. In the year 1999, what is the difference between the Electricity production(% of total) of Estonia and Electricity production(% of total) of Moldova?
Offer a very short reply. -2.32. In the year 1999, what is the difference between the Electricity production(% of total) in Indonesia and Electricity production(% of total) in Moldova?
Offer a very short reply. 30.74. In the year 2000, what is the difference between the Electricity production(% of total) of Europe(developing only) and Electricity production(% of total) of Estonia?
Give a very brief answer. 28.72. In the year 2000, what is the difference between the Electricity production(% of total) in Europe(developing only) and Electricity production(% of total) in Indonesia?
Offer a very short reply. -5.82. In the year 2000, what is the difference between the Electricity production(% of total) in Europe(developing only) and Electricity production(% of total) in Moldova?
Your answer should be compact. 27.67. In the year 2000, what is the difference between the Electricity production(% of total) in Estonia and Electricity production(% of total) in Indonesia?
Your answer should be compact. -34.54. In the year 2000, what is the difference between the Electricity production(% of total) of Estonia and Electricity production(% of total) of Moldova?
Offer a terse response. -1.05. In the year 2000, what is the difference between the Electricity production(% of total) of Indonesia and Electricity production(% of total) of Moldova?
Provide a short and direct response. 33.49. In the year 2001, what is the difference between the Electricity production(% of total) in Europe(developing only) and Electricity production(% of total) in Estonia?
Offer a terse response. 29.79. In the year 2001, what is the difference between the Electricity production(% of total) of Europe(developing only) and Electricity production(% of total) of Indonesia?
Ensure brevity in your answer.  -5.34. In the year 2001, what is the difference between the Electricity production(% of total) in Europe(developing only) and Electricity production(% of total) in Moldova?
Your response must be concise. 29.92. In the year 2001, what is the difference between the Electricity production(% of total) in Estonia and Electricity production(% of total) in Indonesia?
Provide a short and direct response. -35.14. In the year 2001, what is the difference between the Electricity production(% of total) of Estonia and Electricity production(% of total) of Moldova?
Provide a short and direct response. 0.12. In the year 2001, what is the difference between the Electricity production(% of total) in Indonesia and Electricity production(% of total) in Moldova?
Make the answer very short. 35.26. In the year 2002, what is the difference between the Electricity production(% of total) of Europe(developing only) and Electricity production(% of total) of Estonia?
Give a very brief answer. 27.26. In the year 2002, what is the difference between the Electricity production(% of total) in Europe(developing only) and Electricity production(% of total) in Indonesia?
Your response must be concise. -9.22. In the year 2002, what is the difference between the Electricity production(% of total) of Europe(developing only) and Electricity production(% of total) of Moldova?
Make the answer very short. 28.34. In the year 2002, what is the difference between the Electricity production(% of total) in Estonia and Electricity production(% of total) in Indonesia?
Keep it short and to the point. -36.48. In the year 2002, what is the difference between the Electricity production(% of total) of Estonia and Electricity production(% of total) of Moldova?
Make the answer very short. 1.08. In the year 2002, what is the difference between the Electricity production(% of total) of Indonesia and Electricity production(% of total) of Moldova?
Make the answer very short. 37.56. What is the ratio of the Electricity production(% of total) in Europe(developing only) in 1996 to that in 1997?
Offer a terse response. 0.99. What is the ratio of the Electricity production(% of total) of Estonia in 1996 to that in 1997?
Provide a short and direct response. 0.46. What is the ratio of the Electricity production(% of total) in Indonesia in 1996 to that in 1997?
Make the answer very short. 0.9. What is the ratio of the Electricity production(% of total) of Moldova in 1996 to that in 1997?
Provide a succinct answer. 2.45. What is the ratio of the Electricity production(% of total) in Europe(developing only) in 1996 to that in 1998?
Offer a terse response. 1.01. What is the ratio of the Electricity production(% of total) of Estonia in 1996 to that in 1998?
Make the answer very short. 0.34. What is the ratio of the Electricity production(% of total) of Indonesia in 1996 to that in 1998?
Provide a succinct answer. 0.81. What is the ratio of the Electricity production(% of total) of Moldova in 1996 to that in 1998?
Provide a succinct answer. 2.39. What is the ratio of the Electricity production(% of total) of Europe(developing only) in 1996 to that in 1999?
Give a very brief answer. 1.04. What is the ratio of the Electricity production(% of total) of Estonia in 1996 to that in 1999?
Your answer should be compact. 0.34. What is the ratio of the Electricity production(% of total) in Indonesia in 1996 to that in 1999?
Keep it short and to the point. 0.74. What is the ratio of the Electricity production(% of total) of Moldova in 1996 to that in 1999?
Provide a succinct answer. 5.38. What is the ratio of the Electricity production(% of total) of Estonia in 1996 to that in 2000?
Your answer should be very brief. 0.2. What is the ratio of the Electricity production(% of total) of Indonesia in 1996 to that in 2000?
Make the answer very short. 0.69. What is the ratio of the Electricity production(% of total) of Moldova in 1996 to that in 2000?
Give a very brief answer. 6.29. What is the ratio of the Electricity production(% of total) of Europe(developing only) in 1996 to that in 2001?
Give a very brief answer. 0.96. What is the ratio of the Electricity production(% of total) in Estonia in 1996 to that in 2001?
Ensure brevity in your answer.  0.18. What is the ratio of the Electricity production(% of total) in Indonesia in 1996 to that in 2001?
Give a very brief answer. 0.68. What is the ratio of the Electricity production(% of total) of Moldova in 1996 to that in 2001?
Your response must be concise. 9.32. What is the ratio of the Electricity production(% of total) of Europe(developing only) in 1996 to that in 2002?
Offer a very short reply. 1.01. What is the ratio of the Electricity production(% of total) in Estonia in 1996 to that in 2002?
Your answer should be compact. 0.12. What is the ratio of the Electricity production(% of total) in Indonesia in 1996 to that in 2002?
Provide a short and direct response. 0.63. What is the ratio of the Electricity production(% of total) in Moldova in 1996 to that in 2002?
Provide a succinct answer. 8.79. What is the ratio of the Electricity production(% of total) in Europe(developing only) in 1997 to that in 1998?
Offer a very short reply. 1.03. What is the ratio of the Electricity production(% of total) in Estonia in 1997 to that in 1998?
Provide a succinct answer. 0.75. What is the ratio of the Electricity production(% of total) of Indonesia in 1997 to that in 1998?
Offer a very short reply. 0.9. What is the ratio of the Electricity production(% of total) in Moldova in 1997 to that in 1998?
Offer a very short reply. 0.98. What is the ratio of the Electricity production(% of total) of Europe(developing only) in 1997 to that in 1999?
Keep it short and to the point. 1.05. What is the ratio of the Electricity production(% of total) of Estonia in 1997 to that in 1999?
Provide a succinct answer. 0.74. What is the ratio of the Electricity production(% of total) of Indonesia in 1997 to that in 1999?
Keep it short and to the point. 0.82. What is the ratio of the Electricity production(% of total) of Moldova in 1997 to that in 1999?
Offer a terse response. 2.2. What is the ratio of the Electricity production(% of total) in Europe(developing only) in 1997 to that in 2000?
Your response must be concise. 1.01. What is the ratio of the Electricity production(% of total) of Estonia in 1997 to that in 2000?
Provide a short and direct response. 0.44. What is the ratio of the Electricity production(% of total) in Indonesia in 1997 to that in 2000?
Provide a short and direct response. 0.77. What is the ratio of the Electricity production(% of total) in Moldova in 1997 to that in 2000?
Offer a very short reply. 2.57. What is the ratio of the Electricity production(% of total) in Europe(developing only) in 1997 to that in 2001?
Provide a succinct answer. 0.97. What is the ratio of the Electricity production(% of total) in Estonia in 1997 to that in 2001?
Provide a short and direct response. 0.4. What is the ratio of the Electricity production(% of total) in Indonesia in 1997 to that in 2001?
Your answer should be compact. 0.75. What is the ratio of the Electricity production(% of total) in Moldova in 1997 to that in 2001?
Give a very brief answer. 3.81. What is the ratio of the Electricity production(% of total) in Estonia in 1997 to that in 2002?
Give a very brief answer. 0.26. What is the ratio of the Electricity production(% of total) of Indonesia in 1997 to that in 2002?
Your response must be concise. 0.7. What is the ratio of the Electricity production(% of total) of Moldova in 1997 to that in 2002?
Ensure brevity in your answer.  3.59. What is the ratio of the Electricity production(% of total) of Europe(developing only) in 1998 to that in 1999?
Offer a very short reply. 1.02. What is the ratio of the Electricity production(% of total) of Indonesia in 1998 to that in 1999?
Provide a succinct answer. 0.91. What is the ratio of the Electricity production(% of total) of Moldova in 1998 to that in 1999?
Give a very brief answer. 2.25. What is the ratio of the Electricity production(% of total) in Europe(developing only) in 1998 to that in 2000?
Your response must be concise. 0.99. What is the ratio of the Electricity production(% of total) in Estonia in 1998 to that in 2000?
Keep it short and to the point. 0.59. What is the ratio of the Electricity production(% of total) in Indonesia in 1998 to that in 2000?
Offer a terse response. 0.85. What is the ratio of the Electricity production(% of total) of Moldova in 1998 to that in 2000?
Provide a short and direct response. 2.63. What is the ratio of the Electricity production(% of total) of Europe(developing only) in 1998 to that in 2001?
Provide a short and direct response. 0.95. What is the ratio of the Electricity production(% of total) of Estonia in 1998 to that in 2001?
Your response must be concise. 0.53. What is the ratio of the Electricity production(% of total) of Indonesia in 1998 to that in 2001?
Make the answer very short. 0.83. What is the ratio of the Electricity production(% of total) in Moldova in 1998 to that in 2001?
Your answer should be very brief. 3.9. What is the ratio of the Electricity production(% of total) in Estonia in 1998 to that in 2002?
Make the answer very short. 0.35. What is the ratio of the Electricity production(% of total) of Indonesia in 1998 to that in 2002?
Offer a very short reply. 0.78. What is the ratio of the Electricity production(% of total) of Moldova in 1998 to that in 2002?
Give a very brief answer. 3.68. What is the ratio of the Electricity production(% of total) of Europe(developing only) in 1999 to that in 2000?
Ensure brevity in your answer.  0.97. What is the ratio of the Electricity production(% of total) of Estonia in 1999 to that in 2000?
Make the answer very short. 0.59. What is the ratio of the Electricity production(% of total) of Indonesia in 1999 to that in 2000?
Give a very brief answer. 0.94. What is the ratio of the Electricity production(% of total) in Moldova in 1999 to that in 2000?
Provide a short and direct response. 1.17. What is the ratio of the Electricity production(% of total) in Estonia in 1999 to that in 2001?
Your response must be concise. 0.53. What is the ratio of the Electricity production(% of total) in Indonesia in 1999 to that in 2001?
Make the answer very short. 0.92. What is the ratio of the Electricity production(% of total) of Moldova in 1999 to that in 2001?
Offer a terse response. 1.73. What is the ratio of the Electricity production(% of total) of Europe(developing only) in 1999 to that in 2002?
Offer a terse response. 0.97. What is the ratio of the Electricity production(% of total) in Estonia in 1999 to that in 2002?
Make the answer very short. 0.35. What is the ratio of the Electricity production(% of total) of Indonesia in 1999 to that in 2002?
Give a very brief answer. 0.86. What is the ratio of the Electricity production(% of total) of Moldova in 1999 to that in 2002?
Make the answer very short. 1.63. What is the ratio of the Electricity production(% of total) of Europe(developing only) in 2000 to that in 2001?
Give a very brief answer. 0.96. What is the ratio of the Electricity production(% of total) of Estonia in 2000 to that in 2001?
Ensure brevity in your answer.  0.9. What is the ratio of the Electricity production(% of total) of Indonesia in 2000 to that in 2001?
Make the answer very short. 0.98. What is the ratio of the Electricity production(% of total) of Moldova in 2000 to that in 2001?
Ensure brevity in your answer.  1.48. What is the ratio of the Electricity production(% of total) of Europe(developing only) in 2000 to that in 2002?
Provide a short and direct response. 1.01. What is the ratio of the Electricity production(% of total) of Estonia in 2000 to that in 2002?
Ensure brevity in your answer.  0.59. What is the ratio of the Electricity production(% of total) in Indonesia in 2000 to that in 2002?
Your answer should be compact. 0.92. What is the ratio of the Electricity production(% of total) in Moldova in 2000 to that in 2002?
Offer a terse response. 1.4. What is the ratio of the Electricity production(% of total) of Europe(developing only) in 2001 to that in 2002?
Your answer should be very brief. 1.05. What is the ratio of the Electricity production(% of total) of Estonia in 2001 to that in 2002?
Your response must be concise. 0.66. What is the ratio of the Electricity production(% of total) in Indonesia in 2001 to that in 2002?
Ensure brevity in your answer.  0.94. What is the ratio of the Electricity production(% of total) in Moldova in 2001 to that in 2002?
Provide a succinct answer. 0.94. What is the difference between the highest and the second highest Electricity production(% of total) of Europe(developing only)?
Make the answer very short. 0.85. What is the difference between the highest and the second highest Electricity production(% of total) in Estonia?
Provide a short and direct response. 1.08. What is the difference between the highest and the second highest Electricity production(% of total) in Indonesia?
Ensure brevity in your answer.  2.42. What is the difference between the highest and the second highest Electricity production(% of total) of Moldova?
Keep it short and to the point. 10.75. What is the difference between the highest and the lowest Electricity production(% of total) in Europe(developing only)?
Give a very brief answer. 2.23. What is the difference between the highest and the lowest Electricity production(% of total) in Estonia?
Your answer should be very brief. 2.81. What is the difference between the highest and the lowest Electricity production(% of total) of Indonesia?
Provide a succinct answer. 14.51. What is the difference between the highest and the lowest Electricity production(% of total) in Moldova?
Offer a very short reply. 16.52. 